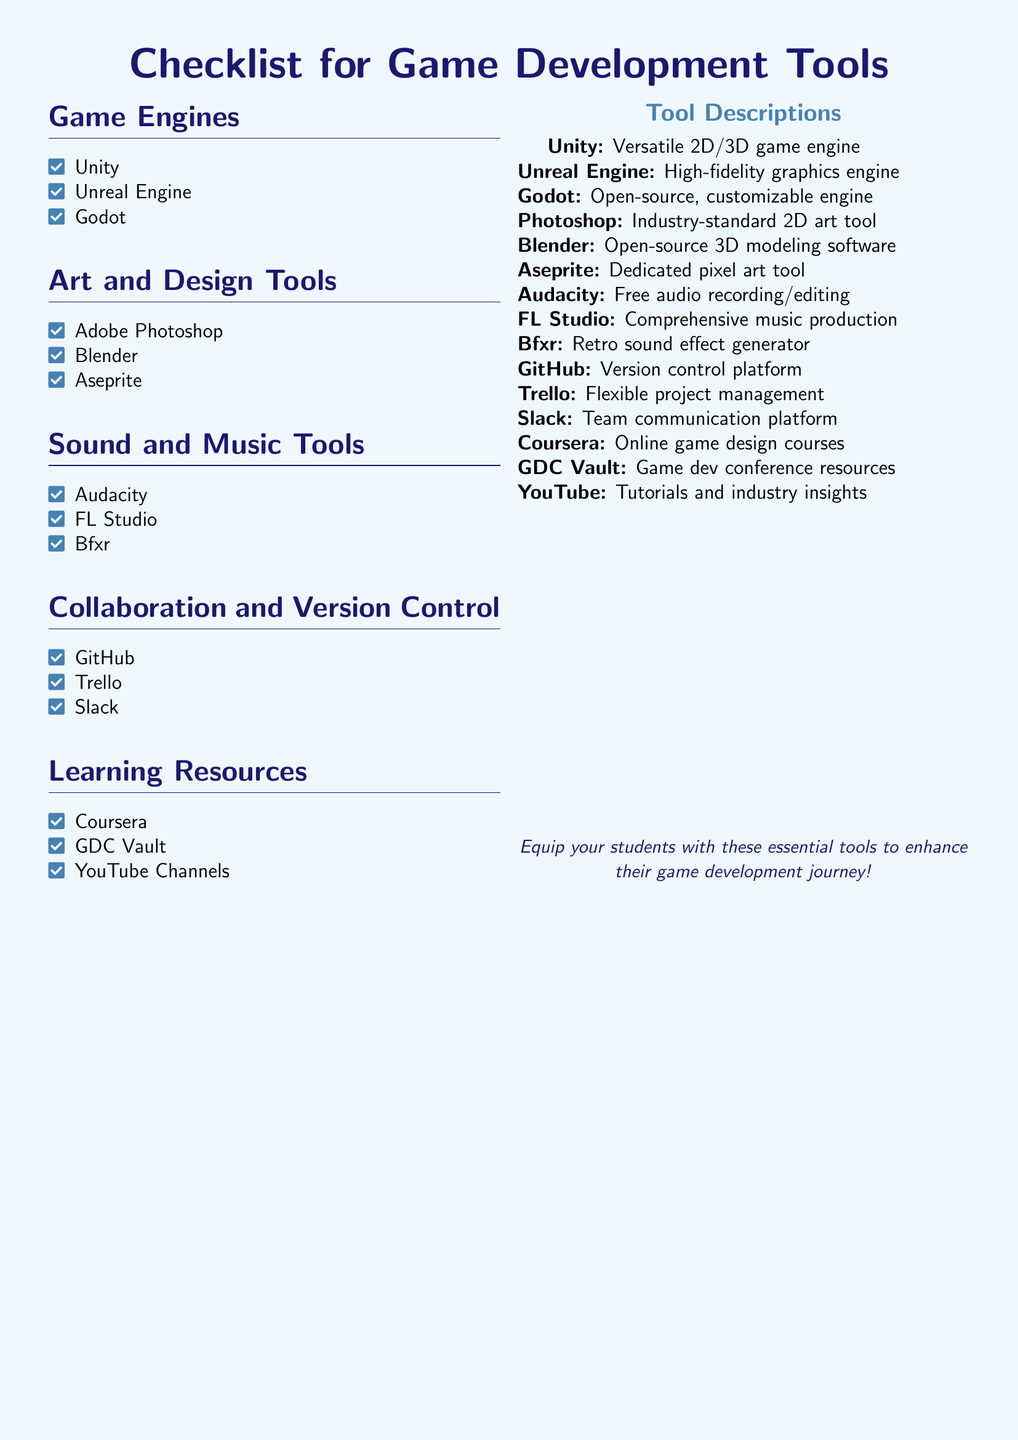What are the three game engines listed? The document lists Unity, Unreal Engine, and Godot under the Game Engines section.
Answer: Unity, Unreal Engine, Godot What is the industry-standard 2D art tool mentioned? The document describes Adobe Photoshop as the industry-standard 2D art tool.
Answer: Adobe Photoshop Which tool is known as a comprehensive music production software? FL Studio is specifically mentioned in the document as a comprehensive music production software.
Answer: FL Studio What platform is used for version control? GitHub is identified in the document as the version control platform.
Answer: GitHub Which online platform offers game design courses? Coursera is highlighted in the document as providing online game design courses.
Answer: Coursera How many art and design tools are listed? The document contains three tools listed under Art and Design Tools: Adobe Photoshop, Blender, and Aseprite.
Answer: 3 What type of resource is GDC Vault? The document states that GDC Vault offers game development conference resources.
Answer: Game dev conference resources Which tool is specifically for retro sound effect generation? Bfxr is mentioned as the retro sound effect generator in the document.
Answer: Bfxr How many collaboration and version control tools are mentioned? There are three tools mentioned under Collaboration and Version Control: GitHub, Trello, and Slack.
Answer: 3 